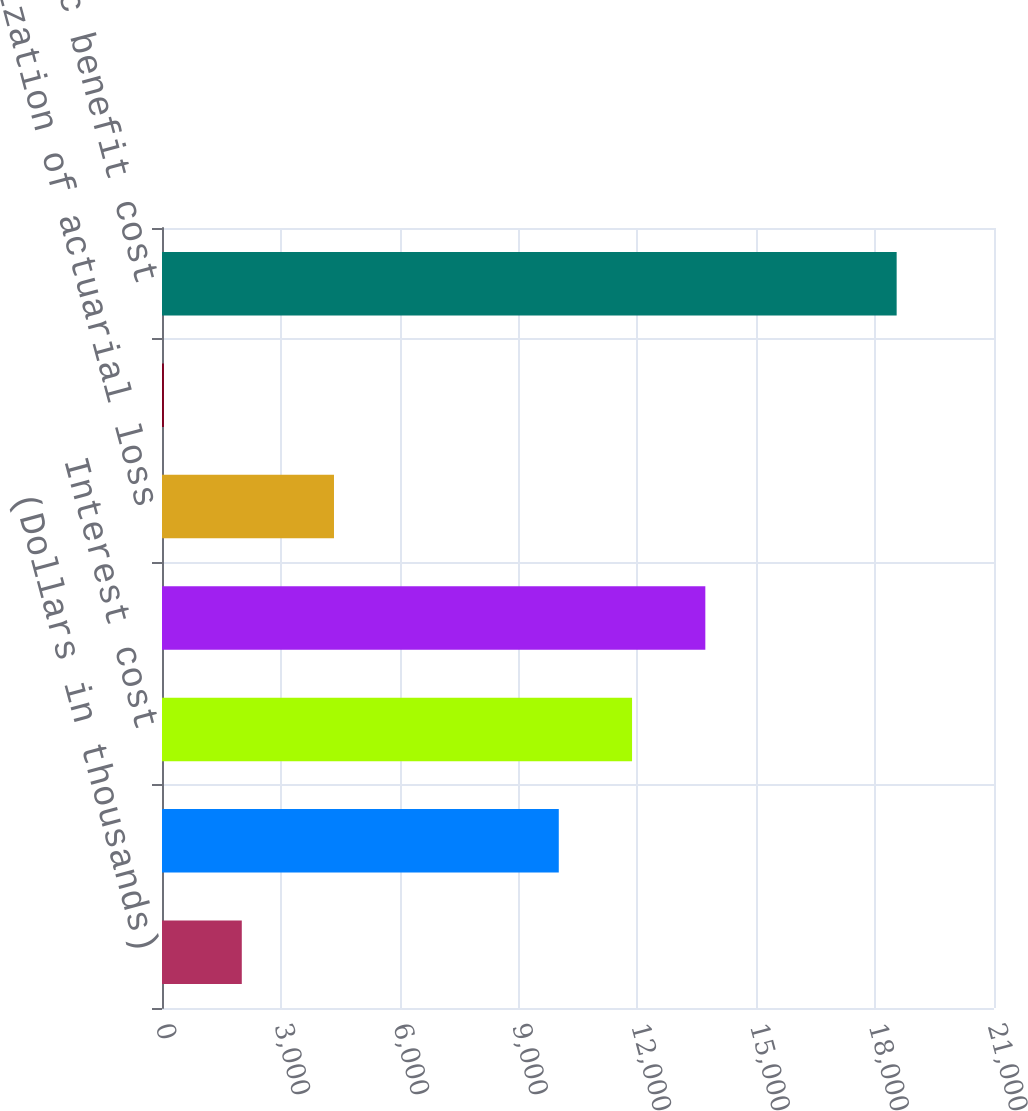Convert chart. <chart><loc_0><loc_0><loc_500><loc_500><bar_chart><fcel>(Dollars in thousands)<fcel>Service cost<fcel>Interest cost<fcel>Expected return on assets<fcel>Amortization of actuarial loss<fcel>Amortization of unrecognized<fcel>Net periodic benefit cost<nl><fcel>2014<fcel>10015<fcel>11864.4<fcel>13713.8<fcel>4341<fcel>49<fcel>18543<nl></chart> 